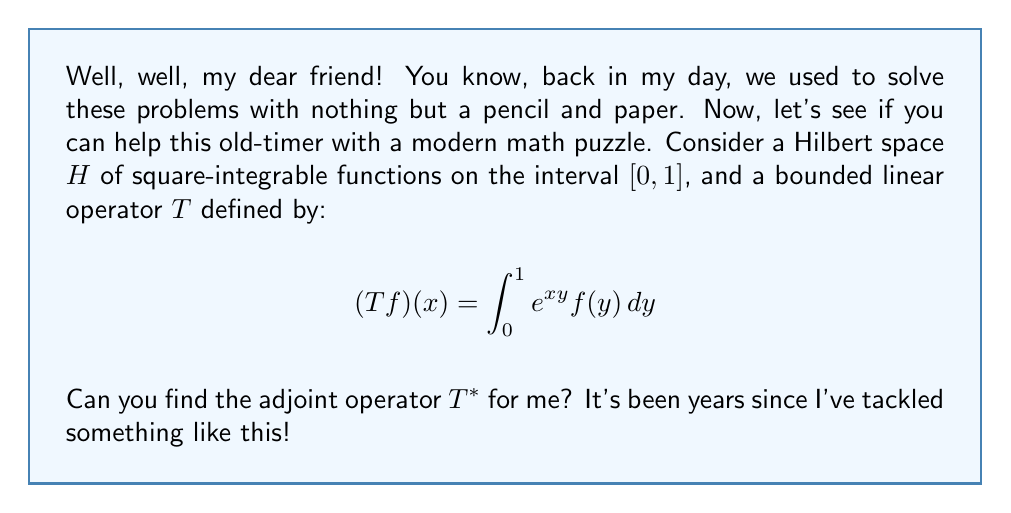Give your solution to this math problem. Certainly! Let's work through this step-by-step, just like we used to do it in the good old days.

1) First, recall that for a bounded linear operator $T$ on a Hilbert space, its adjoint $T^*$ is defined by the relation:

   $$\langle Tf, g \rangle = \langle f, T^*g \rangle$$

   for all $f, g$ in the Hilbert space.

2) In our case, the inner product is defined as:

   $$\langle f, g \rangle = \int_0^1 f(x)g(x)dx$$

3) Let's start by examining the left side of the adjoint definition:

   $$\langle Tf, g \rangle = \int_0^1 (Tf)(x)g(x)dx = \int_0^1 \left(\int_0^1 e^{xy}f(y)dy\right)g(x)dx$$

4) Now, let's change the order of integration (using Fubini's theorem, which is applicable here due to the boundedness of the exponential function on $[0,1] \times [0,1]$):

   $$\int_0^1 \left(\int_0^1 e^{xy}g(x)dx\right)f(y)dy$$

5) Comparing this with the right side of the adjoint definition:

   $$\langle f, T^*g \rangle = \int_0^1 f(y)(T^*g)(y)dy$$

6) We can conclude that:

   $$(T^*g)(y) = \int_0^1 e^{xy}g(x)dx$$

This is the formula for the adjoint operator $T^*$.
Answer: The adjoint operator $T^*$ is given by:

$$(T^*g)(y) = \int_0^1 e^{xy}g(x)dx$$

for all $g$ in the Hilbert space of square-integrable functions on $[0,1]$. 